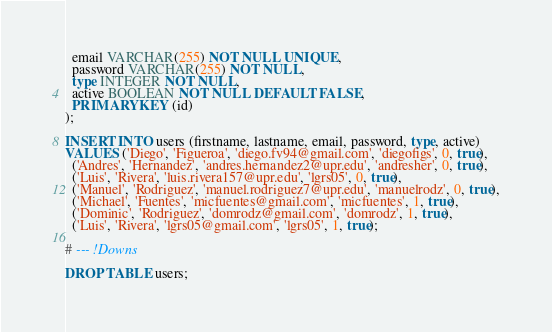<code> <loc_0><loc_0><loc_500><loc_500><_SQL_>  email VARCHAR(255) NOT NULL UNIQUE,
  password VARCHAR(255) NOT NULL,
  type INTEGER NOT NULL,
  active BOOLEAN NOT NULL DEFAULT FALSE,
  PRIMARY KEY (id)
);

INSERT INTO users (firstname, lastname, email, password, type, active)
VALUES ('Diego', 'Figueroa', 'diego.fv94@gmail.com', 'diegofigs', 0, true),
  ('Andres', 'Hernandez', 'andres.hernandez2@upr.edu', 'andresher', 0, true),
  ('Luis', 'Rivera', 'luis.rivera157@upr.edu', 'lgrs05', 0, true),
  ('Manuel', 'Rodriguez', 'manuel.rodriguez7@upr.edu', 'manuelrodz', 0, true),
  ('Michael', 'Fuentes', 'micfuentes@gmail.com', 'micfuentes', 1, true),
  ('Dominic', 'Rodriguez', 'domrodz@gmail.com', 'domrodz', 1, true),
  ('Luis', 'Rivera', 'lgrs05@gmail.com', 'lgrs05', 1, true);

# --- !Downs

DROP TABLE users;</code> 